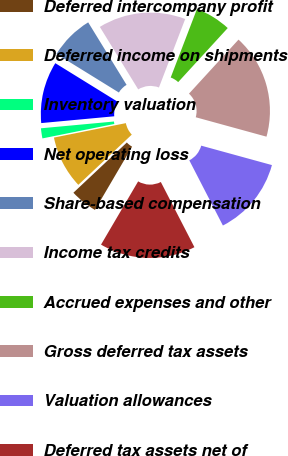Convert chart to OTSL. <chart><loc_0><loc_0><loc_500><loc_500><pie_chart><fcel>Deferred intercompany profit<fcel>Deferred income on shipments<fcel>Inventory valuation<fcel>Net operating loss<fcel>Share-based compensation<fcel>Income tax credits<fcel>Accrued expenses and other<fcel>Gross deferred tax assets<fcel>Valuation allowances<fcel>Deferred tax assets net of<nl><fcel>4.55%<fcel>8.85%<fcel>1.68%<fcel>10.29%<fcel>7.42%<fcel>14.59%<fcel>5.98%<fcel>17.46%<fcel>13.16%<fcel>16.02%<nl></chart> 